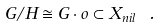<formula> <loc_0><loc_0><loc_500><loc_500>G / H \cong G \cdot o \subset X _ { n i l } \ .</formula> 